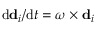Convert formula to latex. <formula><loc_0><loc_0><loc_500><loc_500>d d _ { i } / { d t } = \omega \times d _ { i }</formula> 